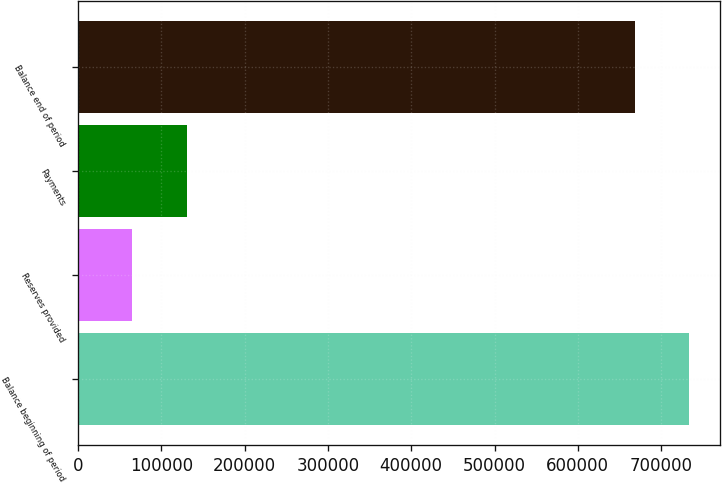Convert chart. <chart><loc_0><loc_0><loc_500><loc_500><bar_chart><fcel>Balance beginning of period<fcel>Reserves provided<fcel>Payments<fcel>Balance end of period<nl><fcel>733755<fcel>64737<fcel>130392<fcel>668100<nl></chart> 